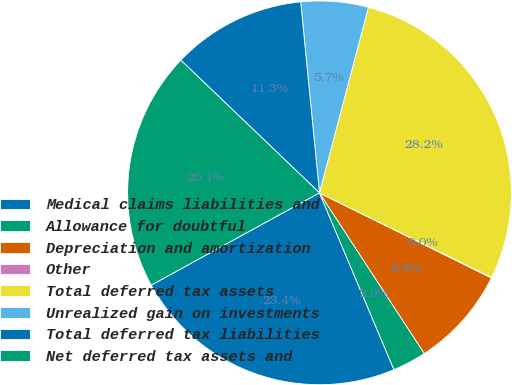Convert chart. <chart><loc_0><loc_0><loc_500><loc_500><pie_chart><fcel>Medical claims liabilities and<fcel>Allowance for doubtful<fcel>Depreciation and amortization<fcel>Other<fcel>Total deferred tax assets<fcel>Unrealized gain on investments<fcel>Total deferred tax liabilities<fcel>Net deferred tax assets and<nl><fcel>23.36%<fcel>2.86%<fcel>8.48%<fcel>0.05%<fcel>28.16%<fcel>5.67%<fcel>11.29%<fcel>20.14%<nl></chart> 